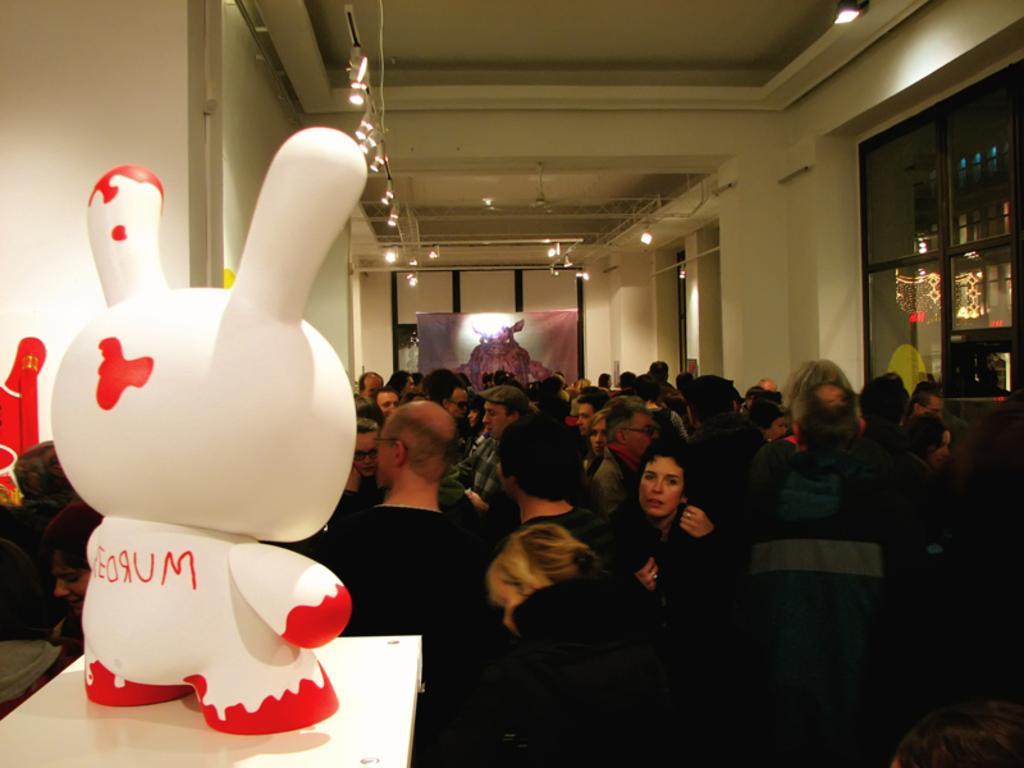Could you give a brief overview of what you see in this image? In this image I can see a crowd on the floor and a doll on the table. In the background I can see a wall, lights, window, poster and shelves. This image is taken in a hall. 